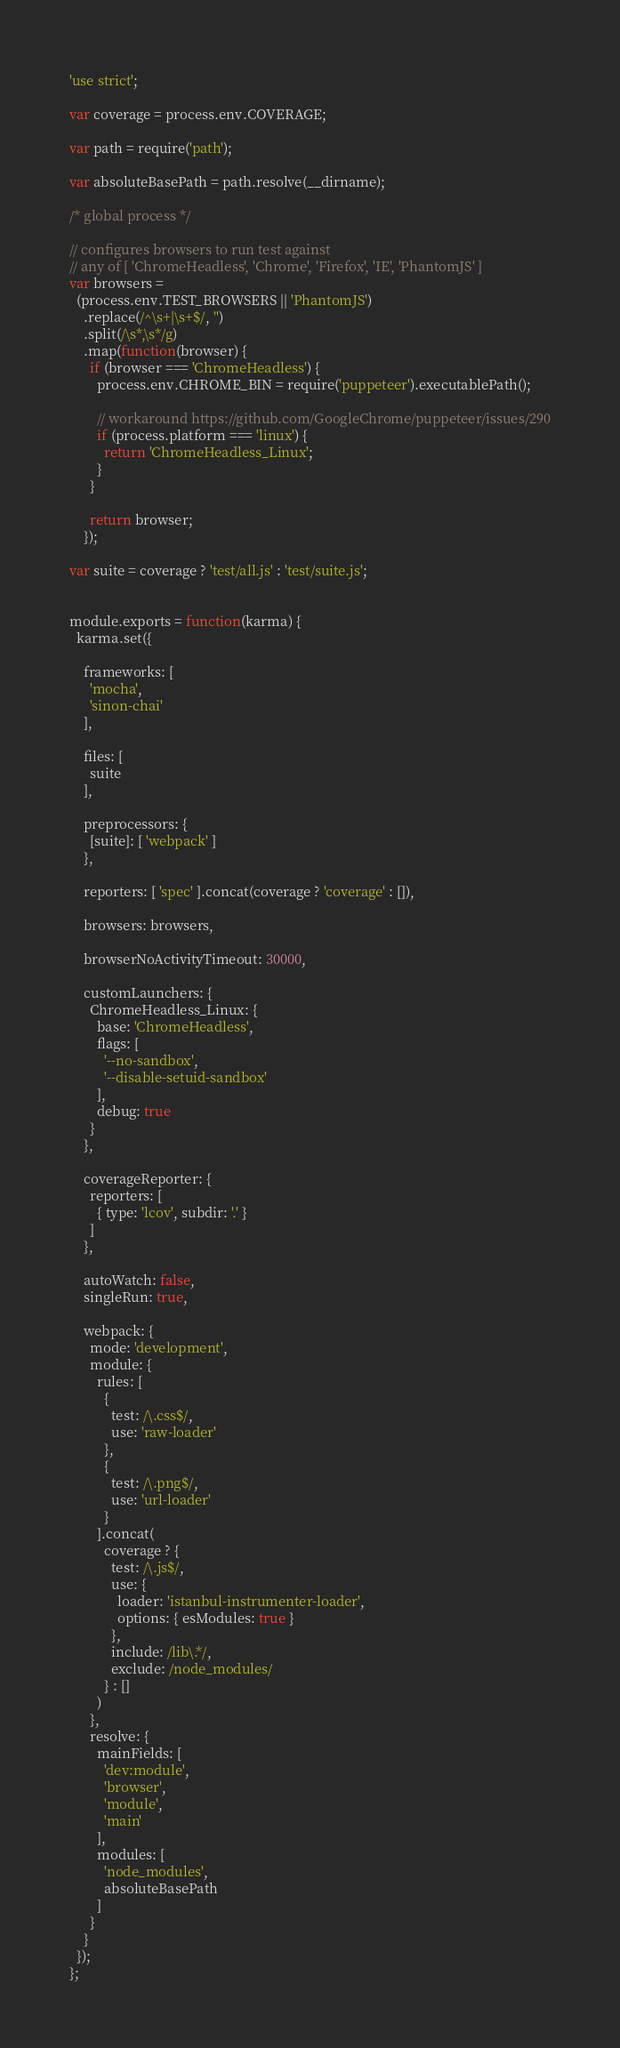Convert code to text. <code><loc_0><loc_0><loc_500><loc_500><_JavaScript_>'use strict';

var coverage = process.env.COVERAGE;

var path = require('path');

var absoluteBasePath = path.resolve(__dirname);

/* global process */

// configures browsers to run test against
// any of [ 'ChromeHeadless', 'Chrome', 'Firefox', 'IE', 'PhantomJS' ]
var browsers =
  (process.env.TEST_BROWSERS || 'PhantomJS')
    .replace(/^\s+|\s+$/, '')
    .split(/\s*,\s*/g)
    .map(function(browser) {
      if (browser === 'ChromeHeadless') {
        process.env.CHROME_BIN = require('puppeteer').executablePath();

        // workaround https://github.com/GoogleChrome/puppeteer/issues/290
        if (process.platform === 'linux') {
          return 'ChromeHeadless_Linux';
        }
      }

      return browser;
    });

var suite = coverage ? 'test/all.js' : 'test/suite.js';


module.exports = function(karma) {
  karma.set({

    frameworks: [
      'mocha',
      'sinon-chai'
    ],

    files: [
      suite
    ],

    preprocessors: {
      [suite]: [ 'webpack' ]
    },

    reporters: [ 'spec' ].concat(coverage ? 'coverage' : []),

    browsers: browsers,

    browserNoActivityTimeout: 30000,

    customLaunchers: {
      ChromeHeadless_Linux: {
        base: 'ChromeHeadless',
        flags: [
          '--no-sandbox',
          '--disable-setuid-sandbox'
        ],
        debug: true
      }
    },

    coverageReporter: {
      reporters: [
        { type: 'lcov', subdir: '.' }
      ]
    },

    autoWatch: false,
    singleRun: true,

    webpack: {
      mode: 'development',
      module: {
        rules: [
          {
            test: /\.css$/,
            use: 'raw-loader'
          },
          {
            test: /\.png$/,
            use: 'url-loader'
          }
        ].concat(
          coverage ? {
            test: /\.js$/,
            use: {
              loader: 'istanbul-instrumenter-loader',
              options: { esModules: true }
            },
            include: /lib\.*/,
            exclude: /node_modules/
          } : []
        )
      },
      resolve: {
        mainFields: [
          'dev:module',
          'browser',
          'module',
          'main'
        ],
        modules: [
          'node_modules',
          absoluteBasePath
        ]
      }
    }
  });
};
</code> 